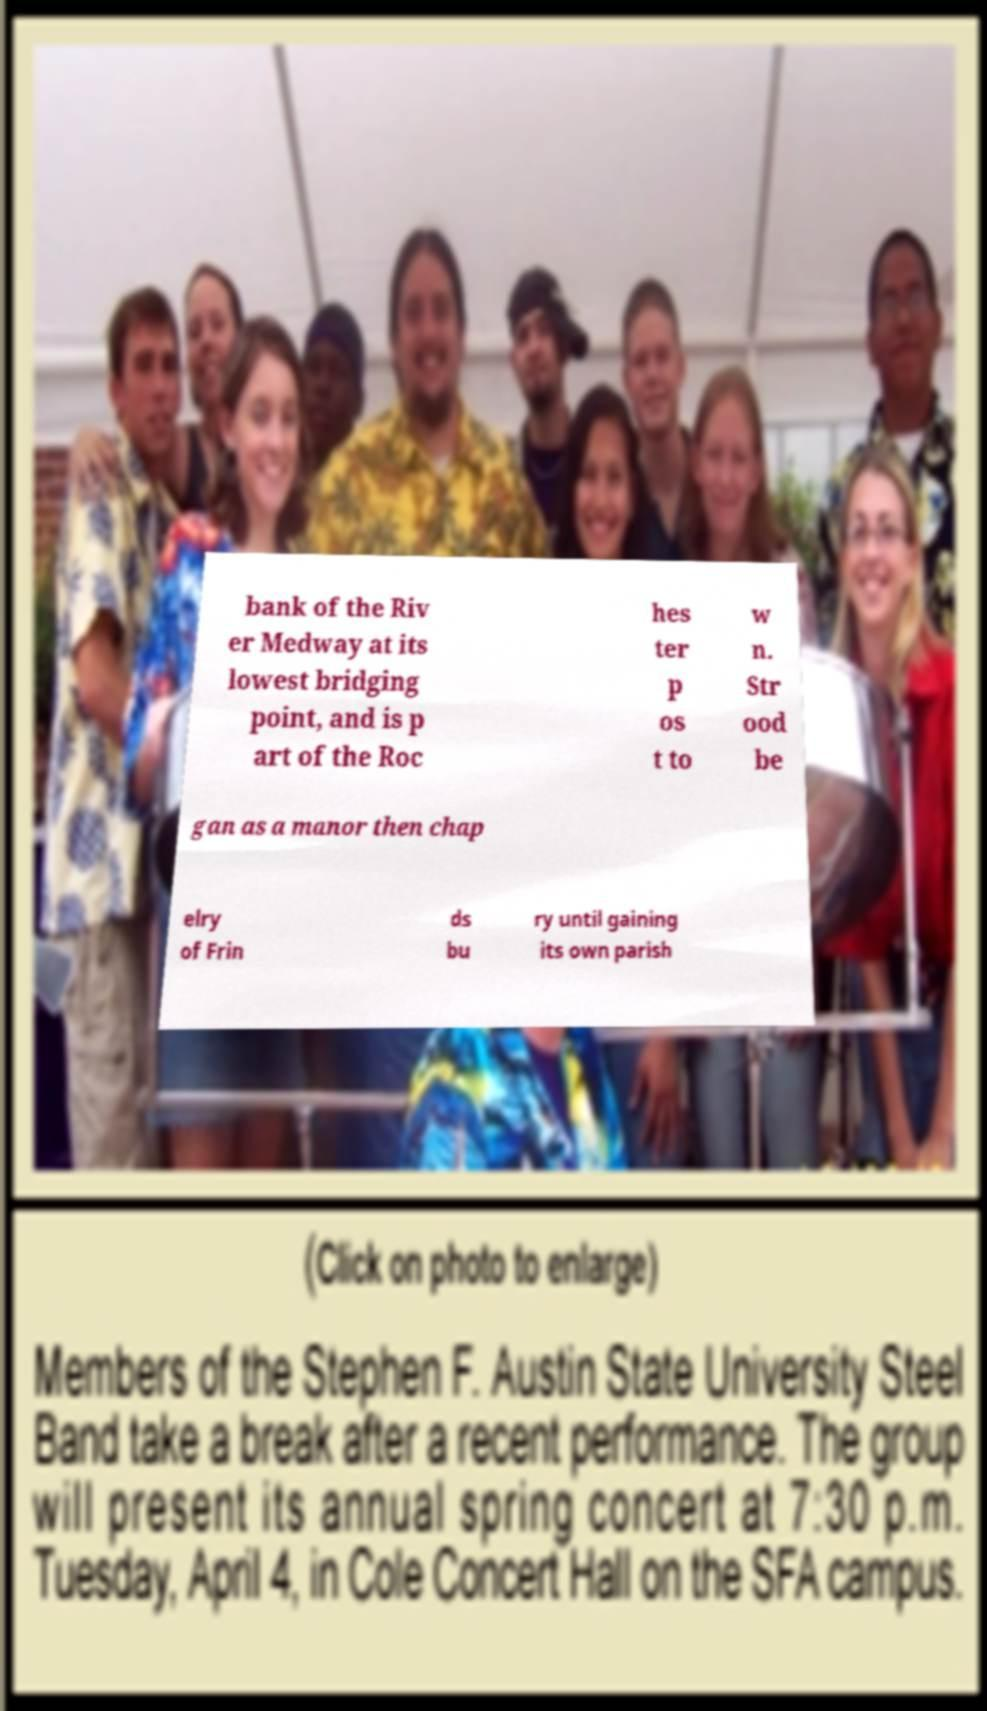What messages or text are displayed in this image? I need them in a readable, typed format. bank of the Riv er Medway at its lowest bridging point, and is p art of the Roc hes ter p os t to w n. Str ood be gan as a manor then chap elry of Frin ds bu ry until gaining its own parish 